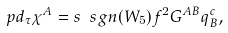Convert formula to latex. <formula><loc_0><loc_0><loc_500><loc_500>\ p d _ { \tau } \chi ^ { A } = s \ s g n ( W _ { 5 } ) f ^ { 2 } G ^ { A B } q _ { B } ^ { c } ,</formula> 